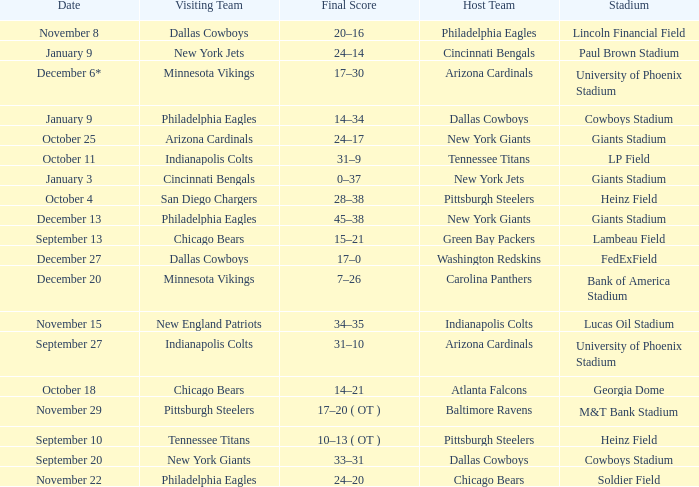Tell me the final score for january 9 for cincinnati bengals 24–14. 